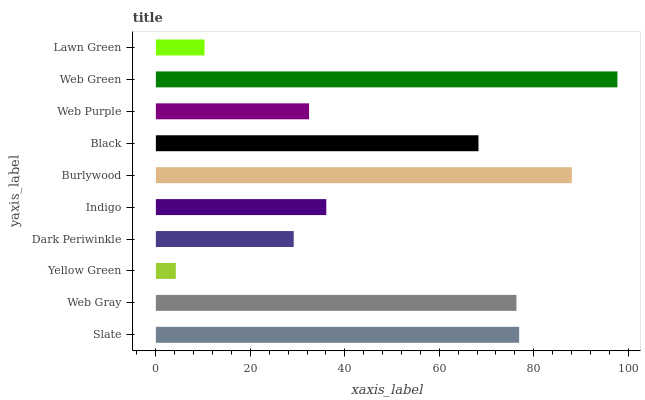Is Yellow Green the minimum?
Answer yes or no. Yes. Is Web Green the maximum?
Answer yes or no. Yes. Is Web Gray the minimum?
Answer yes or no. No. Is Web Gray the maximum?
Answer yes or no. No. Is Slate greater than Web Gray?
Answer yes or no. Yes. Is Web Gray less than Slate?
Answer yes or no. Yes. Is Web Gray greater than Slate?
Answer yes or no. No. Is Slate less than Web Gray?
Answer yes or no. No. Is Black the high median?
Answer yes or no. Yes. Is Indigo the low median?
Answer yes or no. Yes. Is Lawn Green the high median?
Answer yes or no. No. Is Burlywood the low median?
Answer yes or no. No. 